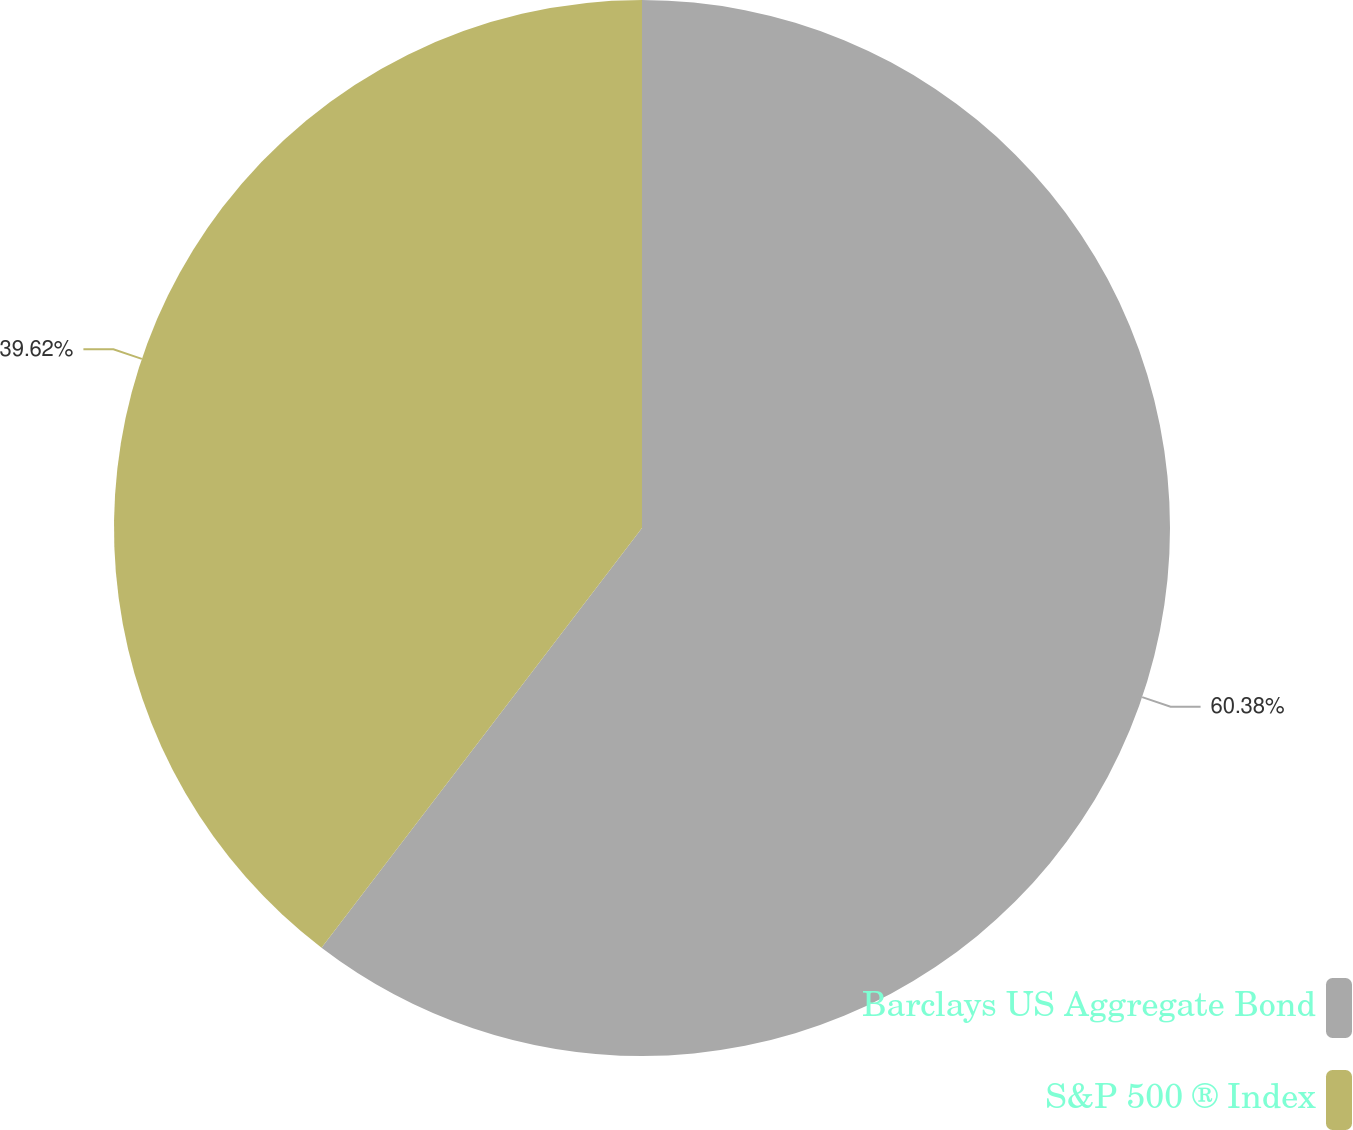Convert chart. <chart><loc_0><loc_0><loc_500><loc_500><pie_chart><fcel>Barclays US Aggregate Bond<fcel>S&P 500 ® Index<nl><fcel>60.38%<fcel>39.62%<nl></chart> 